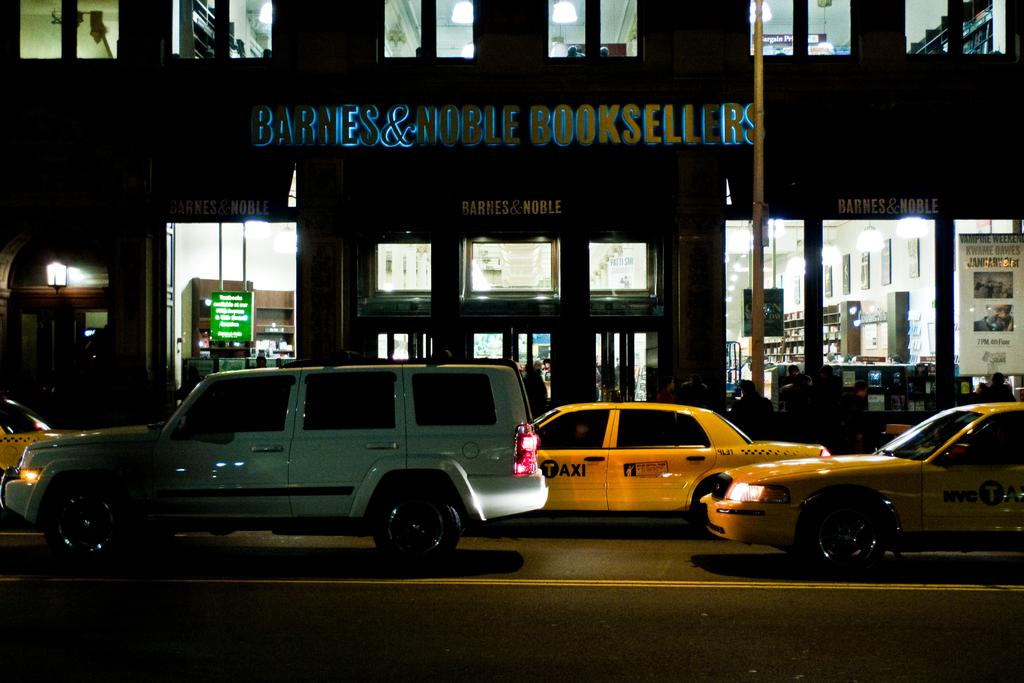<image>
Share a concise interpretation of the image provided. A street in the dark with a Barnes and Noble store in the background. 